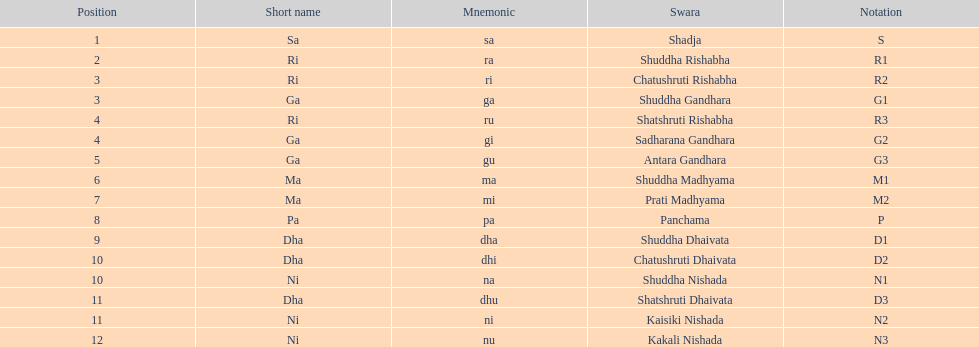Which swara follows immediately after antara gandhara? Shuddha Madhyama. 